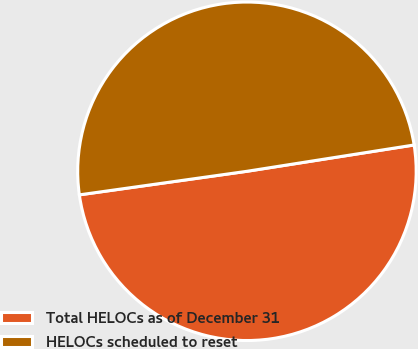Convert chart. <chart><loc_0><loc_0><loc_500><loc_500><pie_chart><fcel>Total HELOCs as of December 31<fcel>HELOCs scheduled to reset<nl><fcel>50.26%<fcel>49.74%<nl></chart> 